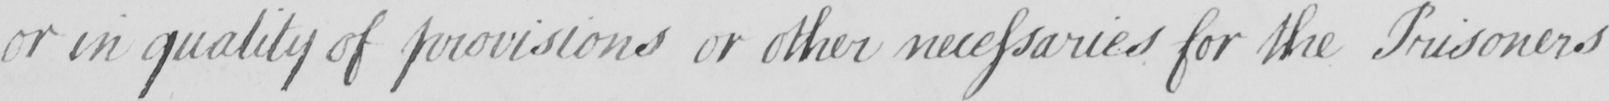Can you read and transcribe this handwriting? or in quality of provisions or other necessaries for the Prisoners 